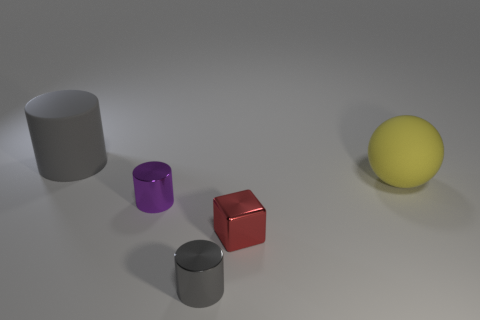Do the big cylinder and the small metal cylinder that is in front of the small red metal object have the same color?
Provide a succinct answer. Yes. What number of other objects are there of the same color as the large rubber cylinder?
Give a very brief answer. 1. Is the number of large yellow balls greater than the number of small cyan matte cubes?
Your answer should be compact. Yes. What is the size of the cylinder that is behind the gray metallic cylinder and on the right side of the gray matte thing?
Your response must be concise. Small. What is the shape of the yellow object?
Your answer should be very brief. Sphere. How many purple objects are the same shape as the red metal object?
Give a very brief answer. 0. Is the number of shiny cylinders that are behind the gray matte cylinder less than the number of cylinders that are behind the small gray object?
Your answer should be compact. Yes. There is a tiny cylinder behind the tiny gray shiny object; how many gray cylinders are in front of it?
Provide a succinct answer. 1. Are there any blue balls?
Provide a succinct answer. No. Are there any small yellow balls made of the same material as the red block?
Your answer should be very brief. No. 